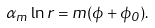<formula> <loc_0><loc_0><loc_500><loc_500>\alpha _ { m } \ln r = m ( \phi + \phi _ { 0 } ) .</formula> 